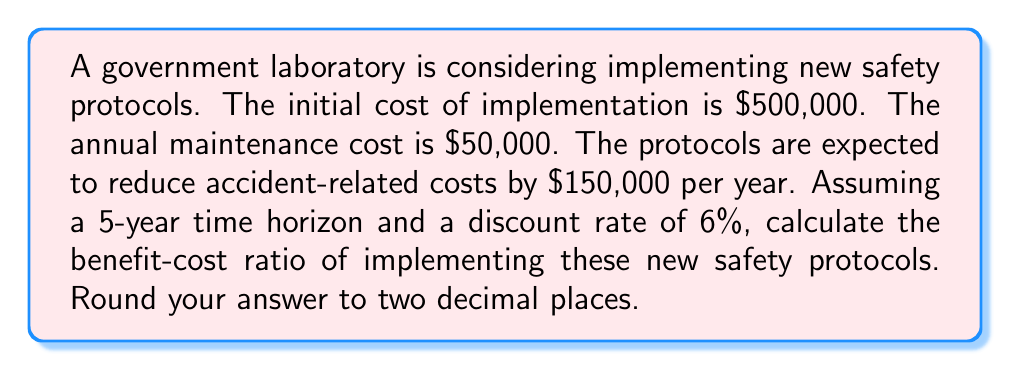What is the answer to this math problem? To calculate the benefit-cost ratio, we need to determine the present value of benefits and costs over the 5-year period.

1. Calculate the present value of costs:
   Initial cost: $500,000
   Annual maintenance cost: $50,000 for 5 years

   Present Value of Costs = $500,000 + $50,000 * (Present Value Annuity Factor)
   
   Where the Present Value Annuity Factor (PVAF) for 5 years at 6% is:
   $$PVAF = \frac{1 - (1 + 0.06)^{-5}}{0.06} = 4.2124$$

   PV of Costs = $500,000 + $50,000 * 4.2124 = $710,620

2. Calculate the present value of benefits:
   Annual benefit (reduced accident costs): $150,000 for 5 years

   Present Value of Benefits = $150,000 * (Present Value Annuity Factor)
   PV of Benefits = $150,000 * 4.2124 = $631,860

3. Calculate the Benefit-Cost Ratio:
   $$Benefit-Cost Ratio = \frac{PV of Benefits}{PV of Costs} = \frac{631,860}{710,620} = 0.8892$$

Rounding to two decimal places: 0.89
Answer: 0.89 